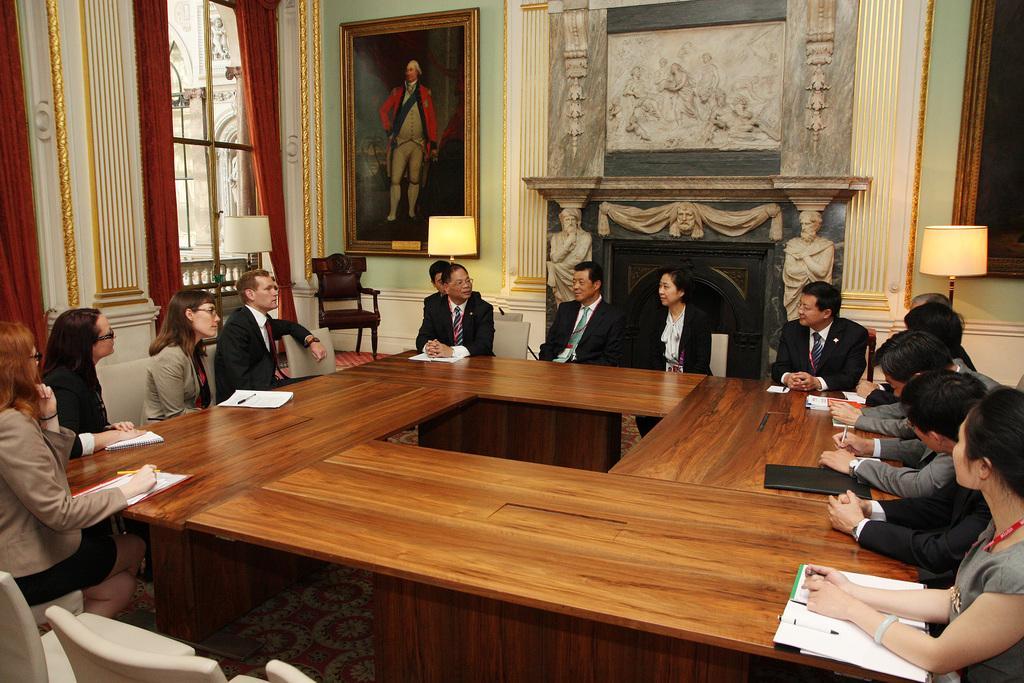Could you give a brief overview of what you see in this image? a meeting is going on. people are sitting around and discussing. behind them there is a photo frame and at the left there are windows and red curtains. 